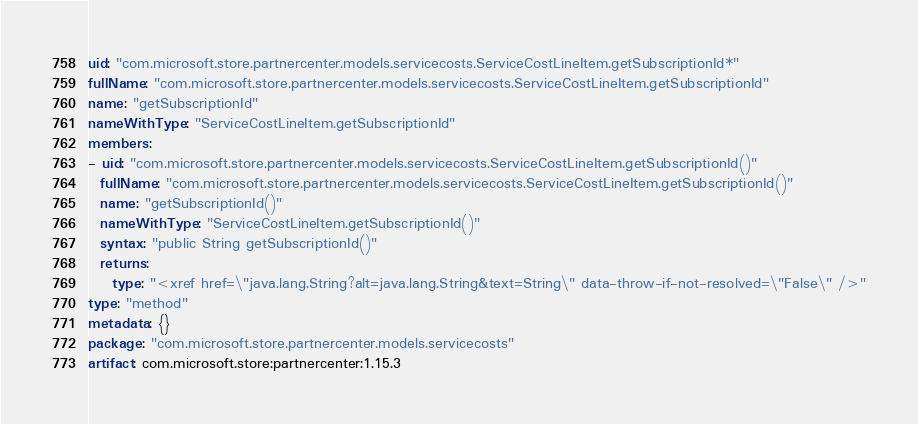<code> <loc_0><loc_0><loc_500><loc_500><_YAML_>uid: "com.microsoft.store.partnercenter.models.servicecosts.ServiceCostLineItem.getSubscriptionId*"
fullName: "com.microsoft.store.partnercenter.models.servicecosts.ServiceCostLineItem.getSubscriptionId"
name: "getSubscriptionId"
nameWithType: "ServiceCostLineItem.getSubscriptionId"
members:
- uid: "com.microsoft.store.partnercenter.models.servicecosts.ServiceCostLineItem.getSubscriptionId()"
  fullName: "com.microsoft.store.partnercenter.models.servicecosts.ServiceCostLineItem.getSubscriptionId()"
  name: "getSubscriptionId()"
  nameWithType: "ServiceCostLineItem.getSubscriptionId()"
  syntax: "public String getSubscriptionId()"
  returns:
    type: "<xref href=\"java.lang.String?alt=java.lang.String&text=String\" data-throw-if-not-resolved=\"False\" />"
type: "method"
metadata: {}
package: "com.microsoft.store.partnercenter.models.servicecosts"
artifact: com.microsoft.store:partnercenter:1.15.3
</code> 